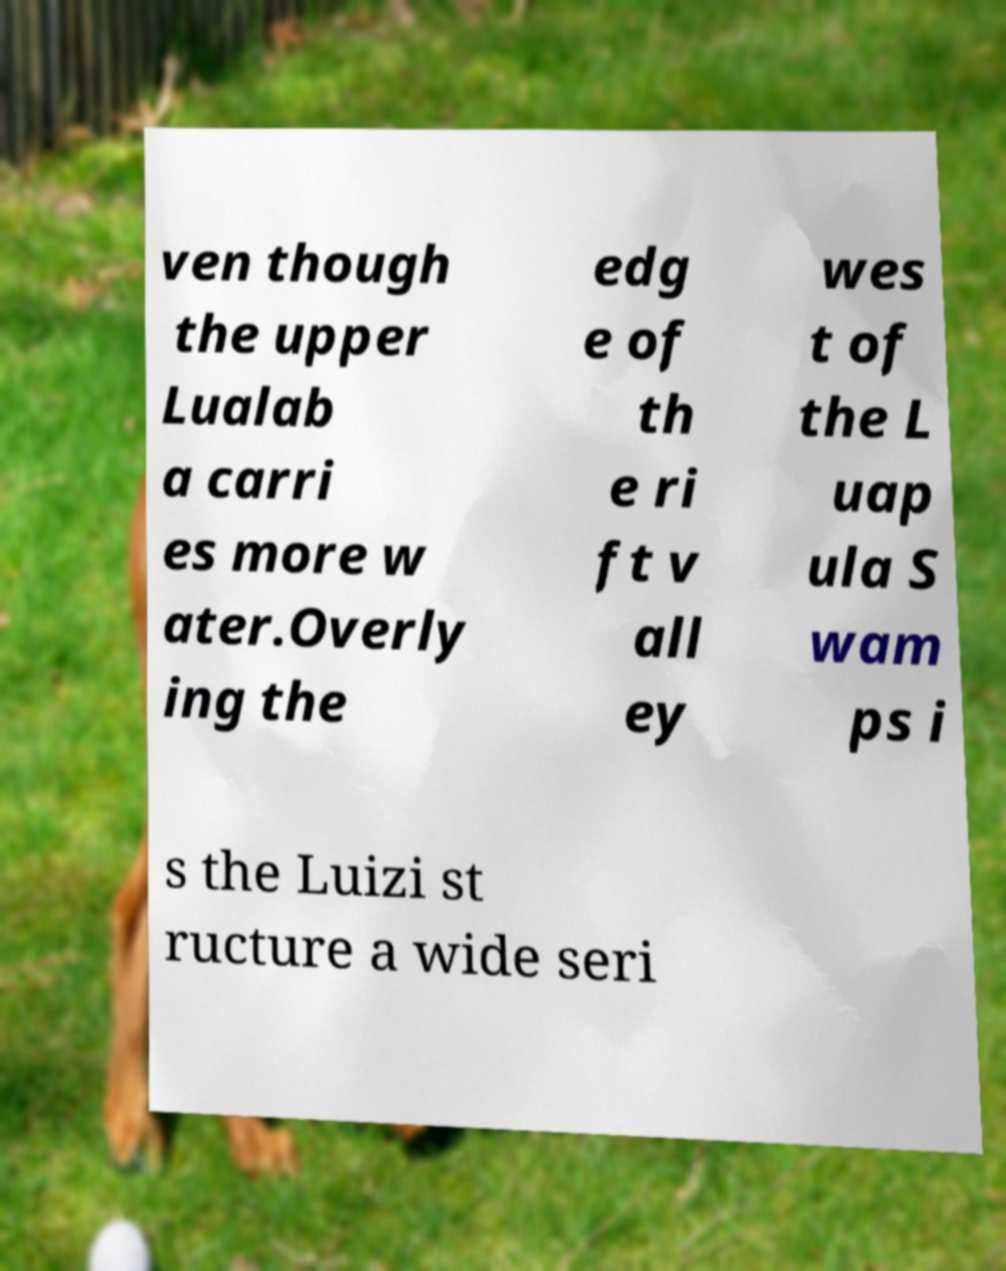There's text embedded in this image that I need extracted. Can you transcribe it verbatim? ven though the upper Lualab a carri es more w ater.Overly ing the edg e of th e ri ft v all ey wes t of the L uap ula S wam ps i s the Luizi st ructure a wide seri 